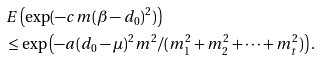<formula> <loc_0><loc_0><loc_500><loc_500>& E \left ( \exp ( - c m ( \beta - d _ { 0 } ) ^ { 2 } ) \right ) \\ & \leq \exp \left ( - a ( d _ { 0 } - \mu ) ^ { 2 } m ^ { 2 } / ( m _ { 1 } ^ { 2 } + m _ { 2 } ^ { 2 } + \dots + m _ { t } ^ { 2 } ) \right ) .</formula> 